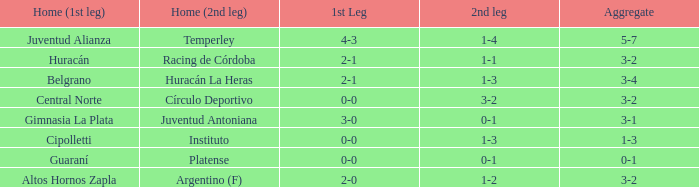What was the score of the 2nd leg when the Belgrano played the first leg at home with a score of 2-1? 1-3. 